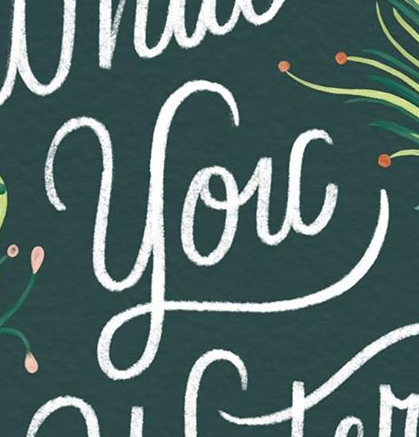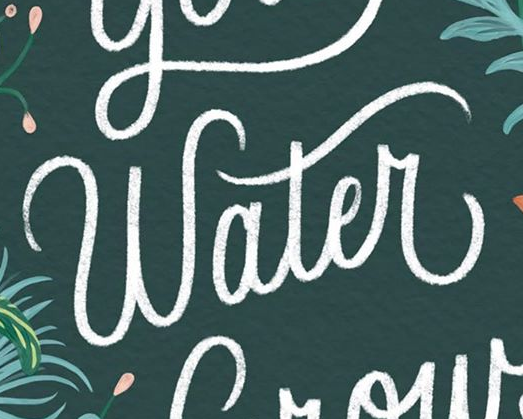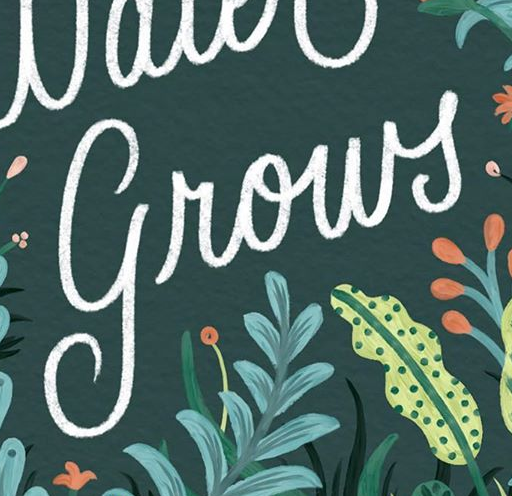What text is displayed in these images sequentially, separated by a semicolon? You; Water; grows 